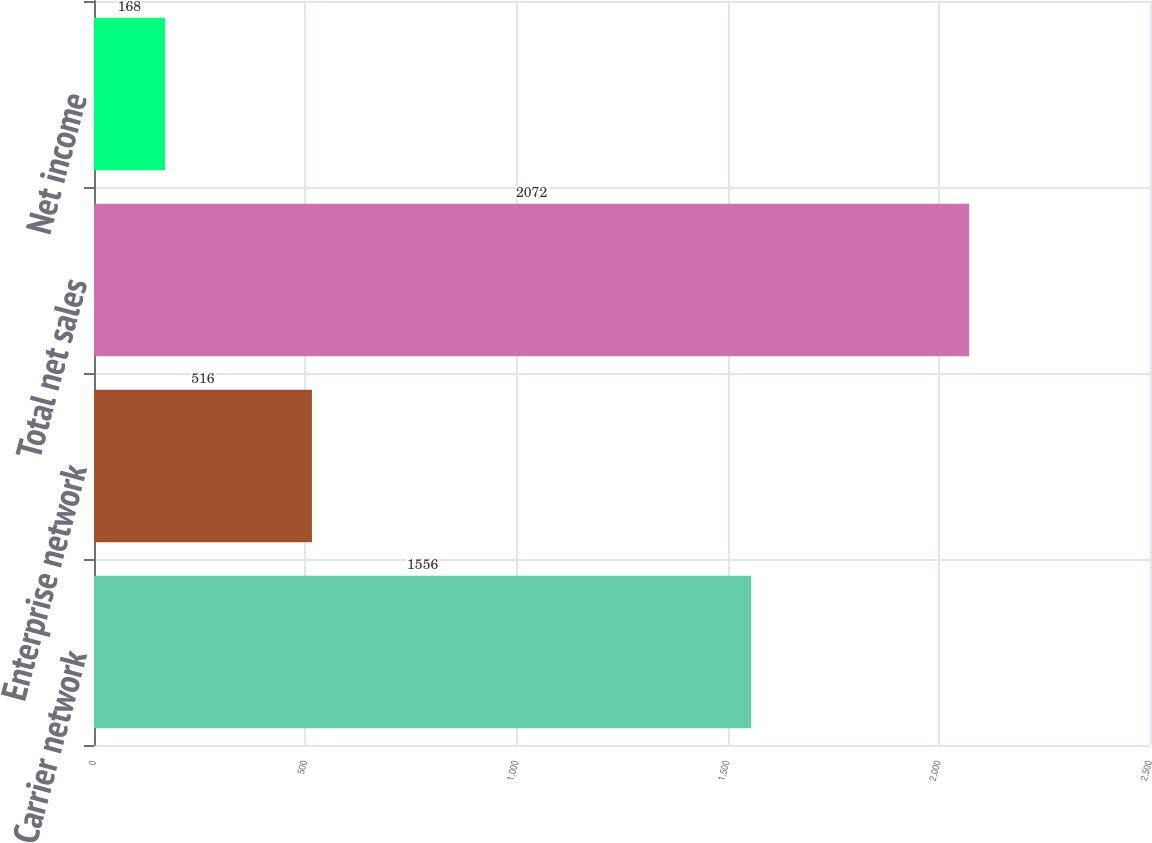Convert chart to OTSL. <chart><loc_0><loc_0><loc_500><loc_500><bar_chart><fcel>Carrier network<fcel>Enterprise network<fcel>Total net sales<fcel>Net income<nl><fcel>1556<fcel>516<fcel>2072<fcel>168<nl></chart> 